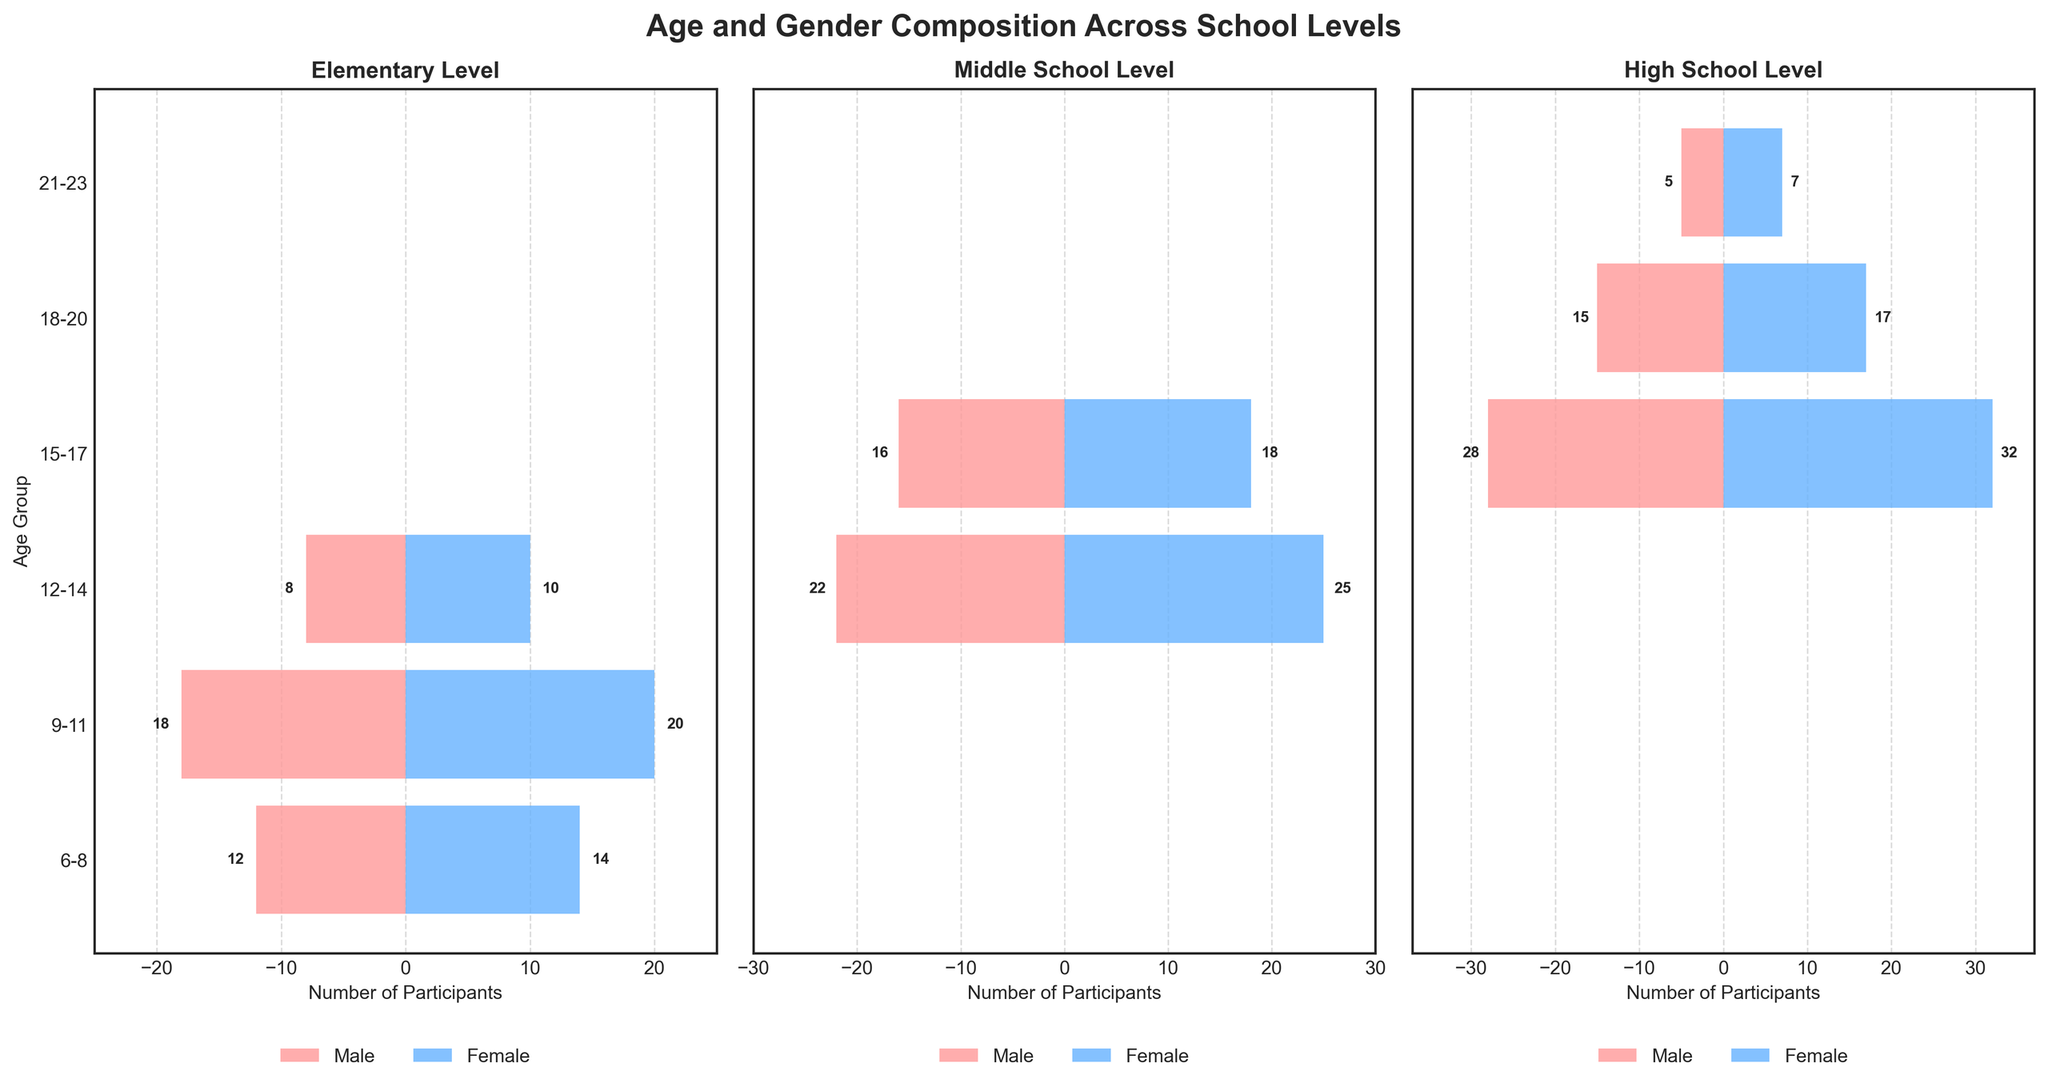What is the title of the figure? The title of the figure is located at the top center and summarizes the main topic of the figure.
Answer: Age and Gender Composition Across School Levels What color represents female participants? By looking at the bar colors in the figure's legend, we identify the color used for female participants.
Answer: Blue How many male participants are there in the 15-17 age group at the High School level? Look at the right horizontal bar for the High School level and find the value associated with the "15-17" age group on the left side (negative side).
Answer: 28 Which school level has the most participants aged 9-11? Compare the horizontal bars for the 9-11 age group across the three school levels and sum both male and female participants for each level to find the highest total. Elementary and Middle School have no participants in this age group. Only Elementary has participants aged 9-11.
Answer: Elementary What is the total number of participants aged 18-20 at the High School level? Add the number of male and female participants for the 18-20 age group at the High School level.
Answer: 32 Which age group has the highest number of female participants at the Middle School level? Compare the lengths of the blue bars for different age groups at the Middle School level.
Answer: 12-14 Are there any participants aged 21-23 in Elementary or Middle School levels? Look at the bars corresponding to the 21-23 age group for both Elementary and Middle School levels and check if any bar is drawn.
Answer: No What is the gender composition of participants aged 12-14 across all school levels? Sum the number of male and female participants for the 12-14 age group at each school level and then compare. In Elementary, there are 8 males and 10 females; in Middle School, there are 22 males and 25 females; there are no participants in High School. Summing up: males = 8+22 = 30, females = 10+25 = 35.
Answer: 30 males, 35 females Which age group at the Middle School level has a higher number of total participants, 12-14 or 15-17? Calculate the total number of participants (both male and female) in each of these age groups at the Middle School level by summing their respective bar lengths. For 12-14, males = 22, females = 25 (total 47); for 15-17, males = 16, females = 18 (total 34).
Answer: 12-14 